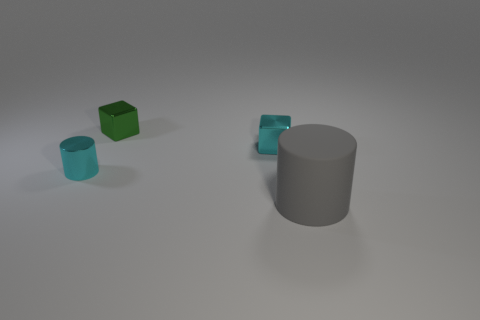Add 2 tiny cyan cylinders. How many objects exist? 6 Add 1 tiny green blocks. How many tiny green blocks exist? 2 Subtract 0 red cubes. How many objects are left? 4 Subtract all large blue metallic objects. Subtract all cyan metal things. How many objects are left? 2 Add 4 big gray rubber things. How many big gray rubber things are left? 5 